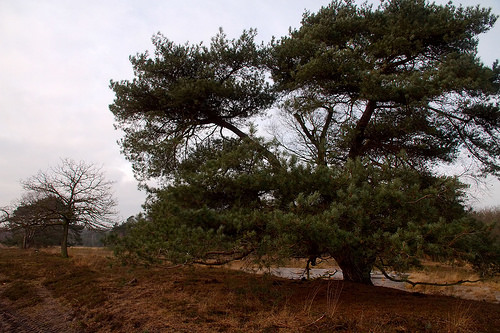<image>
Is there a sky behind the tree? Yes. From this viewpoint, the sky is positioned behind the tree, with the tree partially or fully occluding the sky. 